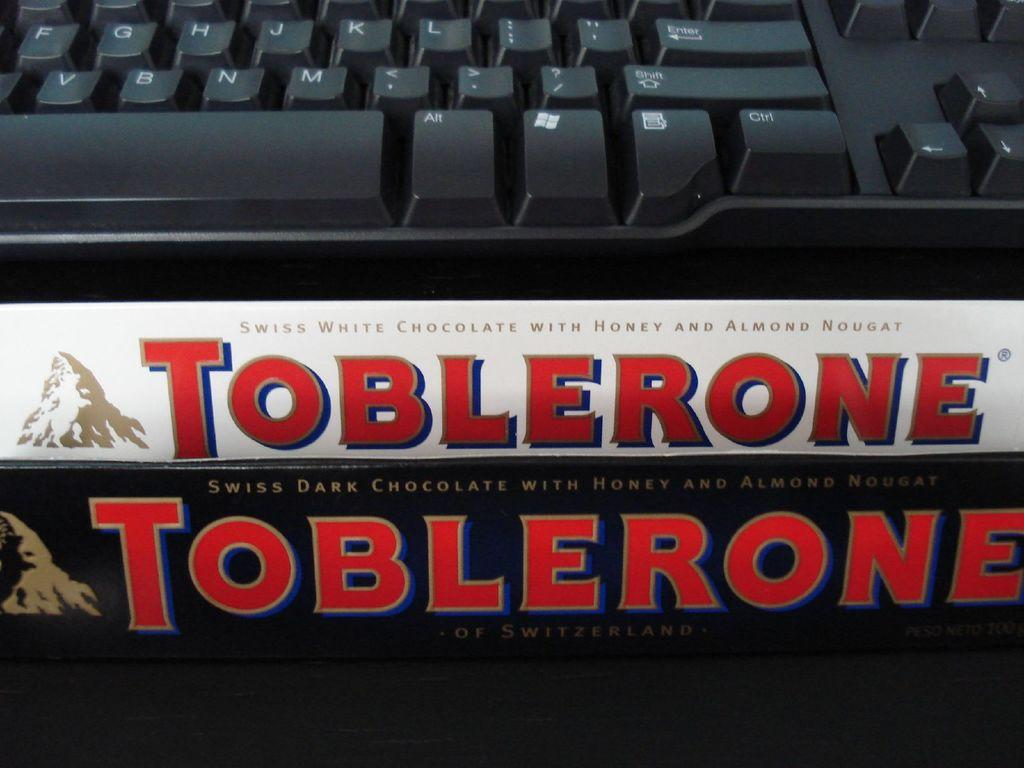<image>
Offer a succinct explanation of the picture presented. Two Toblerone bars, one black one white in front of a keyboard. 